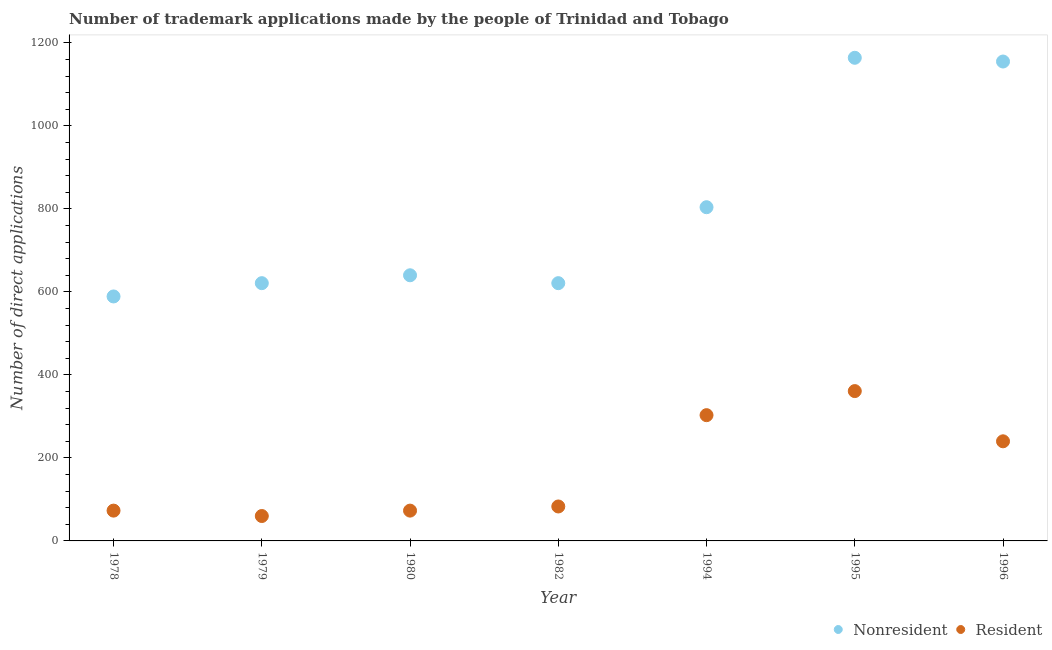What is the number of trademark applications made by non residents in 1982?
Make the answer very short. 621. Across all years, what is the maximum number of trademark applications made by residents?
Provide a short and direct response. 361. Across all years, what is the minimum number of trademark applications made by non residents?
Make the answer very short. 589. In which year was the number of trademark applications made by non residents minimum?
Your response must be concise. 1978. What is the total number of trademark applications made by non residents in the graph?
Offer a very short reply. 5594. What is the difference between the number of trademark applications made by residents in 1979 and that in 1996?
Ensure brevity in your answer.  -180. What is the difference between the number of trademark applications made by residents in 1994 and the number of trademark applications made by non residents in 1996?
Provide a short and direct response. -852. What is the average number of trademark applications made by residents per year?
Your answer should be compact. 170.43. In the year 1995, what is the difference between the number of trademark applications made by residents and number of trademark applications made by non residents?
Your answer should be very brief. -803. What is the ratio of the number of trademark applications made by residents in 1978 to that in 1982?
Provide a short and direct response. 0.88. Is the difference between the number of trademark applications made by residents in 1980 and 1995 greater than the difference between the number of trademark applications made by non residents in 1980 and 1995?
Ensure brevity in your answer.  Yes. What is the difference between the highest and the lowest number of trademark applications made by non residents?
Give a very brief answer. 575. In how many years, is the number of trademark applications made by residents greater than the average number of trademark applications made by residents taken over all years?
Make the answer very short. 3. Is the sum of the number of trademark applications made by non residents in 1978 and 1979 greater than the maximum number of trademark applications made by residents across all years?
Provide a short and direct response. Yes. Is the number of trademark applications made by non residents strictly greater than the number of trademark applications made by residents over the years?
Provide a succinct answer. Yes. Is the number of trademark applications made by residents strictly less than the number of trademark applications made by non residents over the years?
Ensure brevity in your answer.  Yes. What is the difference between two consecutive major ticks on the Y-axis?
Provide a short and direct response. 200. Are the values on the major ticks of Y-axis written in scientific E-notation?
Offer a very short reply. No. Does the graph contain grids?
Provide a succinct answer. No. How many legend labels are there?
Make the answer very short. 2. How are the legend labels stacked?
Provide a short and direct response. Horizontal. What is the title of the graph?
Your response must be concise. Number of trademark applications made by the people of Trinidad and Tobago. What is the label or title of the Y-axis?
Provide a short and direct response. Number of direct applications. What is the Number of direct applications in Nonresident in 1978?
Give a very brief answer. 589. What is the Number of direct applications of Resident in 1978?
Offer a terse response. 73. What is the Number of direct applications of Nonresident in 1979?
Make the answer very short. 621. What is the Number of direct applications of Resident in 1979?
Give a very brief answer. 60. What is the Number of direct applications of Nonresident in 1980?
Provide a succinct answer. 640. What is the Number of direct applications in Nonresident in 1982?
Ensure brevity in your answer.  621. What is the Number of direct applications in Nonresident in 1994?
Make the answer very short. 804. What is the Number of direct applications of Resident in 1994?
Offer a very short reply. 303. What is the Number of direct applications in Nonresident in 1995?
Your answer should be compact. 1164. What is the Number of direct applications in Resident in 1995?
Offer a very short reply. 361. What is the Number of direct applications in Nonresident in 1996?
Provide a succinct answer. 1155. What is the Number of direct applications of Resident in 1996?
Make the answer very short. 240. Across all years, what is the maximum Number of direct applications in Nonresident?
Provide a short and direct response. 1164. Across all years, what is the maximum Number of direct applications in Resident?
Your answer should be compact. 361. Across all years, what is the minimum Number of direct applications of Nonresident?
Ensure brevity in your answer.  589. What is the total Number of direct applications of Nonresident in the graph?
Your response must be concise. 5594. What is the total Number of direct applications of Resident in the graph?
Provide a succinct answer. 1193. What is the difference between the Number of direct applications in Nonresident in 1978 and that in 1979?
Offer a terse response. -32. What is the difference between the Number of direct applications in Nonresident in 1978 and that in 1980?
Make the answer very short. -51. What is the difference between the Number of direct applications of Nonresident in 1978 and that in 1982?
Keep it short and to the point. -32. What is the difference between the Number of direct applications of Nonresident in 1978 and that in 1994?
Provide a short and direct response. -215. What is the difference between the Number of direct applications of Resident in 1978 and that in 1994?
Provide a short and direct response. -230. What is the difference between the Number of direct applications in Nonresident in 1978 and that in 1995?
Your response must be concise. -575. What is the difference between the Number of direct applications of Resident in 1978 and that in 1995?
Give a very brief answer. -288. What is the difference between the Number of direct applications of Nonresident in 1978 and that in 1996?
Your response must be concise. -566. What is the difference between the Number of direct applications in Resident in 1978 and that in 1996?
Offer a very short reply. -167. What is the difference between the Number of direct applications of Resident in 1979 and that in 1980?
Make the answer very short. -13. What is the difference between the Number of direct applications in Nonresident in 1979 and that in 1994?
Provide a succinct answer. -183. What is the difference between the Number of direct applications in Resident in 1979 and that in 1994?
Offer a terse response. -243. What is the difference between the Number of direct applications in Nonresident in 1979 and that in 1995?
Provide a short and direct response. -543. What is the difference between the Number of direct applications of Resident in 1979 and that in 1995?
Provide a short and direct response. -301. What is the difference between the Number of direct applications of Nonresident in 1979 and that in 1996?
Keep it short and to the point. -534. What is the difference between the Number of direct applications of Resident in 1979 and that in 1996?
Your answer should be very brief. -180. What is the difference between the Number of direct applications of Nonresident in 1980 and that in 1982?
Offer a very short reply. 19. What is the difference between the Number of direct applications in Resident in 1980 and that in 1982?
Offer a terse response. -10. What is the difference between the Number of direct applications in Nonresident in 1980 and that in 1994?
Keep it short and to the point. -164. What is the difference between the Number of direct applications in Resident in 1980 and that in 1994?
Provide a succinct answer. -230. What is the difference between the Number of direct applications in Nonresident in 1980 and that in 1995?
Your answer should be very brief. -524. What is the difference between the Number of direct applications of Resident in 1980 and that in 1995?
Offer a terse response. -288. What is the difference between the Number of direct applications of Nonresident in 1980 and that in 1996?
Give a very brief answer. -515. What is the difference between the Number of direct applications in Resident in 1980 and that in 1996?
Offer a terse response. -167. What is the difference between the Number of direct applications in Nonresident in 1982 and that in 1994?
Make the answer very short. -183. What is the difference between the Number of direct applications in Resident in 1982 and that in 1994?
Your response must be concise. -220. What is the difference between the Number of direct applications of Nonresident in 1982 and that in 1995?
Your answer should be very brief. -543. What is the difference between the Number of direct applications in Resident in 1982 and that in 1995?
Provide a short and direct response. -278. What is the difference between the Number of direct applications of Nonresident in 1982 and that in 1996?
Give a very brief answer. -534. What is the difference between the Number of direct applications in Resident in 1982 and that in 1996?
Keep it short and to the point. -157. What is the difference between the Number of direct applications in Nonresident in 1994 and that in 1995?
Ensure brevity in your answer.  -360. What is the difference between the Number of direct applications of Resident in 1994 and that in 1995?
Provide a short and direct response. -58. What is the difference between the Number of direct applications of Nonresident in 1994 and that in 1996?
Make the answer very short. -351. What is the difference between the Number of direct applications in Resident in 1994 and that in 1996?
Provide a short and direct response. 63. What is the difference between the Number of direct applications of Nonresident in 1995 and that in 1996?
Your answer should be compact. 9. What is the difference between the Number of direct applications of Resident in 1995 and that in 1996?
Provide a succinct answer. 121. What is the difference between the Number of direct applications of Nonresident in 1978 and the Number of direct applications of Resident in 1979?
Provide a succinct answer. 529. What is the difference between the Number of direct applications of Nonresident in 1978 and the Number of direct applications of Resident in 1980?
Offer a very short reply. 516. What is the difference between the Number of direct applications of Nonresident in 1978 and the Number of direct applications of Resident in 1982?
Keep it short and to the point. 506. What is the difference between the Number of direct applications in Nonresident in 1978 and the Number of direct applications in Resident in 1994?
Provide a short and direct response. 286. What is the difference between the Number of direct applications in Nonresident in 1978 and the Number of direct applications in Resident in 1995?
Your response must be concise. 228. What is the difference between the Number of direct applications of Nonresident in 1978 and the Number of direct applications of Resident in 1996?
Provide a short and direct response. 349. What is the difference between the Number of direct applications in Nonresident in 1979 and the Number of direct applications in Resident in 1980?
Provide a short and direct response. 548. What is the difference between the Number of direct applications in Nonresident in 1979 and the Number of direct applications in Resident in 1982?
Offer a terse response. 538. What is the difference between the Number of direct applications of Nonresident in 1979 and the Number of direct applications of Resident in 1994?
Offer a very short reply. 318. What is the difference between the Number of direct applications in Nonresident in 1979 and the Number of direct applications in Resident in 1995?
Offer a terse response. 260. What is the difference between the Number of direct applications in Nonresident in 1979 and the Number of direct applications in Resident in 1996?
Your answer should be very brief. 381. What is the difference between the Number of direct applications in Nonresident in 1980 and the Number of direct applications in Resident in 1982?
Provide a short and direct response. 557. What is the difference between the Number of direct applications of Nonresident in 1980 and the Number of direct applications of Resident in 1994?
Make the answer very short. 337. What is the difference between the Number of direct applications in Nonresident in 1980 and the Number of direct applications in Resident in 1995?
Provide a succinct answer. 279. What is the difference between the Number of direct applications of Nonresident in 1982 and the Number of direct applications of Resident in 1994?
Offer a very short reply. 318. What is the difference between the Number of direct applications in Nonresident in 1982 and the Number of direct applications in Resident in 1995?
Your answer should be compact. 260. What is the difference between the Number of direct applications of Nonresident in 1982 and the Number of direct applications of Resident in 1996?
Offer a terse response. 381. What is the difference between the Number of direct applications of Nonresident in 1994 and the Number of direct applications of Resident in 1995?
Your response must be concise. 443. What is the difference between the Number of direct applications in Nonresident in 1994 and the Number of direct applications in Resident in 1996?
Your answer should be compact. 564. What is the difference between the Number of direct applications in Nonresident in 1995 and the Number of direct applications in Resident in 1996?
Offer a terse response. 924. What is the average Number of direct applications of Nonresident per year?
Ensure brevity in your answer.  799.14. What is the average Number of direct applications in Resident per year?
Your answer should be compact. 170.43. In the year 1978, what is the difference between the Number of direct applications in Nonresident and Number of direct applications in Resident?
Provide a succinct answer. 516. In the year 1979, what is the difference between the Number of direct applications of Nonresident and Number of direct applications of Resident?
Offer a very short reply. 561. In the year 1980, what is the difference between the Number of direct applications of Nonresident and Number of direct applications of Resident?
Offer a very short reply. 567. In the year 1982, what is the difference between the Number of direct applications in Nonresident and Number of direct applications in Resident?
Your answer should be very brief. 538. In the year 1994, what is the difference between the Number of direct applications of Nonresident and Number of direct applications of Resident?
Provide a succinct answer. 501. In the year 1995, what is the difference between the Number of direct applications in Nonresident and Number of direct applications in Resident?
Ensure brevity in your answer.  803. In the year 1996, what is the difference between the Number of direct applications in Nonresident and Number of direct applications in Resident?
Ensure brevity in your answer.  915. What is the ratio of the Number of direct applications of Nonresident in 1978 to that in 1979?
Your answer should be very brief. 0.95. What is the ratio of the Number of direct applications of Resident in 1978 to that in 1979?
Keep it short and to the point. 1.22. What is the ratio of the Number of direct applications of Nonresident in 1978 to that in 1980?
Make the answer very short. 0.92. What is the ratio of the Number of direct applications in Nonresident in 1978 to that in 1982?
Your answer should be very brief. 0.95. What is the ratio of the Number of direct applications in Resident in 1978 to that in 1982?
Offer a very short reply. 0.88. What is the ratio of the Number of direct applications in Nonresident in 1978 to that in 1994?
Keep it short and to the point. 0.73. What is the ratio of the Number of direct applications in Resident in 1978 to that in 1994?
Provide a short and direct response. 0.24. What is the ratio of the Number of direct applications in Nonresident in 1978 to that in 1995?
Your answer should be compact. 0.51. What is the ratio of the Number of direct applications of Resident in 1978 to that in 1995?
Provide a succinct answer. 0.2. What is the ratio of the Number of direct applications of Nonresident in 1978 to that in 1996?
Your answer should be compact. 0.51. What is the ratio of the Number of direct applications in Resident in 1978 to that in 1996?
Give a very brief answer. 0.3. What is the ratio of the Number of direct applications in Nonresident in 1979 to that in 1980?
Make the answer very short. 0.97. What is the ratio of the Number of direct applications of Resident in 1979 to that in 1980?
Give a very brief answer. 0.82. What is the ratio of the Number of direct applications in Resident in 1979 to that in 1982?
Your response must be concise. 0.72. What is the ratio of the Number of direct applications in Nonresident in 1979 to that in 1994?
Your answer should be compact. 0.77. What is the ratio of the Number of direct applications of Resident in 1979 to that in 1994?
Make the answer very short. 0.2. What is the ratio of the Number of direct applications in Nonresident in 1979 to that in 1995?
Give a very brief answer. 0.53. What is the ratio of the Number of direct applications in Resident in 1979 to that in 1995?
Your answer should be compact. 0.17. What is the ratio of the Number of direct applications of Nonresident in 1979 to that in 1996?
Your answer should be very brief. 0.54. What is the ratio of the Number of direct applications in Nonresident in 1980 to that in 1982?
Your response must be concise. 1.03. What is the ratio of the Number of direct applications of Resident in 1980 to that in 1982?
Give a very brief answer. 0.88. What is the ratio of the Number of direct applications in Nonresident in 1980 to that in 1994?
Your answer should be compact. 0.8. What is the ratio of the Number of direct applications in Resident in 1980 to that in 1994?
Keep it short and to the point. 0.24. What is the ratio of the Number of direct applications in Nonresident in 1980 to that in 1995?
Make the answer very short. 0.55. What is the ratio of the Number of direct applications of Resident in 1980 to that in 1995?
Offer a terse response. 0.2. What is the ratio of the Number of direct applications in Nonresident in 1980 to that in 1996?
Your answer should be very brief. 0.55. What is the ratio of the Number of direct applications of Resident in 1980 to that in 1996?
Offer a very short reply. 0.3. What is the ratio of the Number of direct applications of Nonresident in 1982 to that in 1994?
Make the answer very short. 0.77. What is the ratio of the Number of direct applications of Resident in 1982 to that in 1994?
Ensure brevity in your answer.  0.27. What is the ratio of the Number of direct applications in Nonresident in 1982 to that in 1995?
Your answer should be very brief. 0.53. What is the ratio of the Number of direct applications of Resident in 1982 to that in 1995?
Provide a succinct answer. 0.23. What is the ratio of the Number of direct applications in Nonresident in 1982 to that in 1996?
Make the answer very short. 0.54. What is the ratio of the Number of direct applications in Resident in 1982 to that in 1996?
Offer a very short reply. 0.35. What is the ratio of the Number of direct applications in Nonresident in 1994 to that in 1995?
Your answer should be compact. 0.69. What is the ratio of the Number of direct applications in Resident in 1994 to that in 1995?
Provide a succinct answer. 0.84. What is the ratio of the Number of direct applications of Nonresident in 1994 to that in 1996?
Keep it short and to the point. 0.7. What is the ratio of the Number of direct applications in Resident in 1994 to that in 1996?
Your answer should be very brief. 1.26. What is the ratio of the Number of direct applications in Nonresident in 1995 to that in 1996?
Ensure brevity in your answer.  1.01. What is the ratio of the Number of direct applications in Resident in 1995 to that in 1996?
Provide a short and direct response. 1.5. What is the difference between the highest and the second highest Number of direct applications of Resident?
Offer a terse response. 58. What is the difference between the highest and the lowest Number of direct applications in Nonresident?
Provide a short and direct response. 575. What is the difference between the highest and the lowest Number of direct applications in Resident?
Give a very brief answer. 301. 